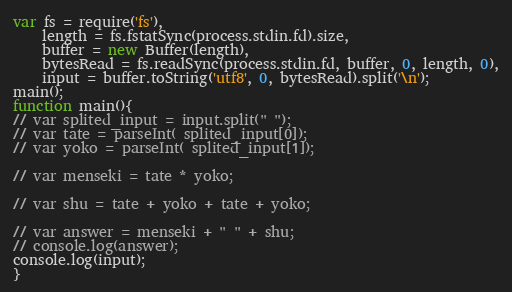Convert code to text. <code><loc_0><loc_0><loc_500><loc_500><_JavaScript_>var fs = require('fs'),
    length = fs.fstatSync(process.stdin.fd).size,
    buffer = new Buffer(length),
    bytesRead = fs.readSync(process.stdin.fd, buffer, 0, length, 0),
    input = buffer.toString('utf8', 0, bytesRead).split('\n');
main();
function main(){
// var splited_input = input.split(" ");
// var tate = parseInt( splited_input[0]);
// var yoko = parseInt( splited_input[1]);

// var menseki = tate * yoko;

// var shu = tate + yoko + tate + yoko;

// var answer = menseki + " " + shu;
// console.log(answer);
console.log(input);
}
</code> 